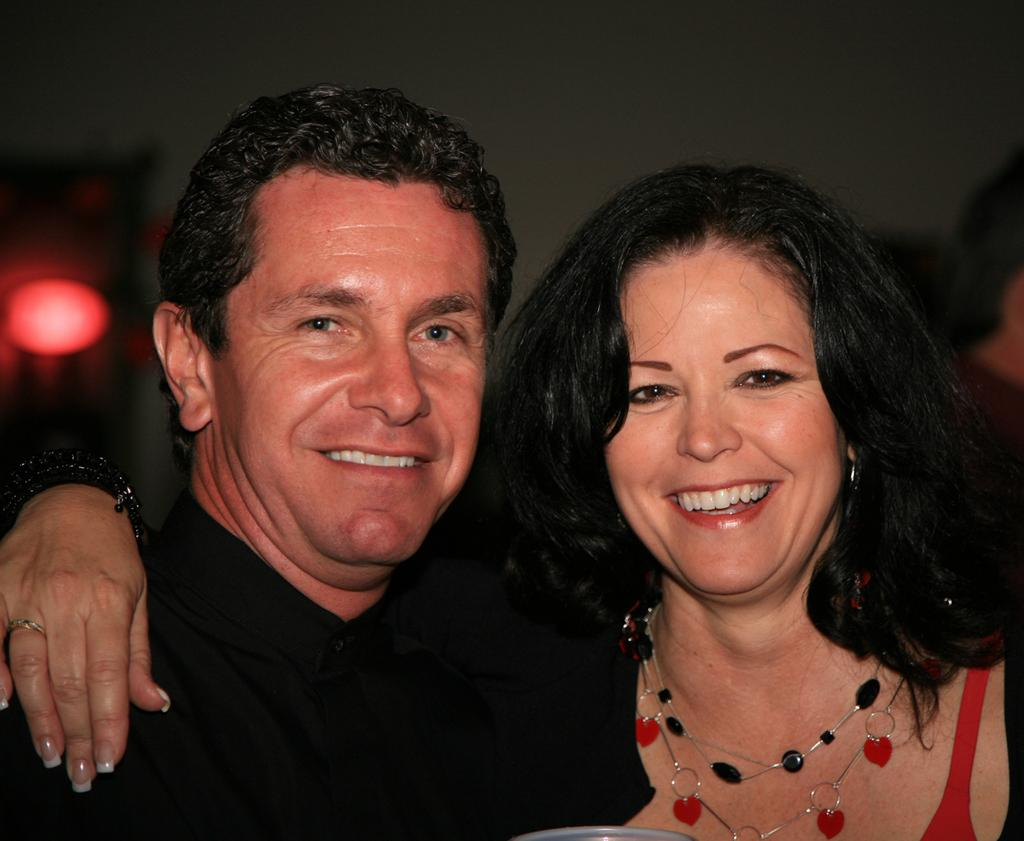How many people are in the image? There are two people in the image. What are the people doing in the image? The people are laughing and posing for a photo. Can you describe the background of the people in the image? The background of the people is blurred. What type of star can be seen in the image? There is no star visible in the image; it features two people laughing and posing for a photo. 